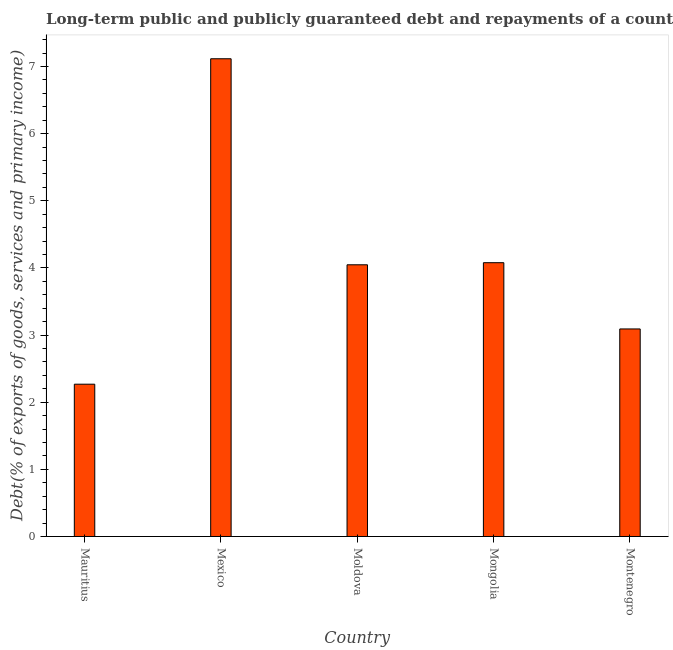Does the graph contain any zero values?
Your response must be concise. No. What is the title of the graph?
Keep it short and to the point. Long-term public and publicly guaranteed debt and repayments of a country to the IMF in 2009. What is the label or title of the X-axis?
Provide a succinct answer. Country. What is the label or title of the Y-axis?
Provide a short and direct response. Debt(% of exports of goods, services and primary income). What is the debt service in Mongolia?
Give a very brief answer. 4.08. Across all countries, what is the maximum debt service?
Give a very brief answer. 7.12. Across all countries, what is the minimum debt service?
Ensure brevity in your answer.  2.27. In which country was the debt service maximum?
Offer a terse response. Mexico. In which country was the debt service minimum?
Your answer should be compact. Mauritius. What is the sum of the debt service?
Offer a terse response. 20.6. What is the difference between the debt service in Mauritius and Mongolia?
Your answer should be very brief. -1.81. What is the average debt service per country?
Offer a very short reply. 4.12. What is the median debt service?
Your answer should be very brief. 4.05. What is the ratio of the debt service in Mauritius to that in Moldova?
Offer a terse response. 0.56. Is the debt service in Mongolia less than that in Montenegro?
Ensure brevity in your answer.  No. What is the difference between the highest and the second highest debt service?
Offer a terse response. 3.04. Is the sum of the debt service in Mongolia and Montenegro greater than the maximum debt service across all countries?
Offer a terse response. Yes. What is the difference between the highest and the lowest debt service?
Ensure brevity in your answer.  4.85. In how many countries, is the debt service greater than the average debt service taken over all countries?
Keep it short and to the point. 1. How many bars are there?
Your answer should be compact. 5. Are the values on the major ticks of Y-axis written in scientific E-notation?
Provide a succinct answer. No. What is the Debt(% of exports of goods, services and primary income) in Mauritius?
Provide a succinct answer. 2.27. What is the Debt(% of exports of goods, services and primary income) in Mexico?
Offer a terse response. 7.12. What is the Debt(% of exports of goods, services and primary income) in Moldova?
Give a very brief answer. 4.05. What is the Debt(% of exports of goods, services and primary income) of Mongolia?
Offer a very short reply. 4.08. What is the Debt(% of exports of goods, services and primary income) of Montenegro?
Give a very brief answer. 3.09. What is the difference between the Debt(% of exports of goods, services and primary income) in Mauritius and Mexico?
Ensure brevity in your answer.  -4.85. What is the difference between the Debt(% of exports of goods, services and primary income) in Mauritius and Moldova?
Your answer should be compact. -1.78. What is the difference between the Debt(% of exports of goods, services and primary income) in Mauritius and Mongolia?
Offer a terse response. -1.81. What is the difference between the Debt(% of exports of goods, services and primary income) in Mauritius and Montenegro?
Give a very brief answer. -0.82. What is the difference between the Debt(% of exports of goods, services and primary income) in Mexico and Moldova?
Keep it short and to the point. 3.07. What is the difference between the Debt(% of exports of goods, services and primary income) in Mexico and Mongolia?
Your answer should be very brief. 3.04. What is the difference between the Debt(% of exports of goods, services and primary income) in Mexico and Montenegro?
Your answer should be compact. 4.02. What is the difference between the Debt(% of exports of goods, services and primary income) in Moldova and Mongolia?
Offer a very short reply. -0.03. What is the difference between the Debt(% of exports of goods, services and primary income) in Moldova and Montenegro?
Keep it short and to the point. 0.96. What is the difference between the Debt(% of exports of goods, services and primary income) in Mongolia and Montenegro?
Provide a short and direct response. 0.99. What is the ratio of the Debt(% of exports of goods, services and primary income) in Mauritius to that in Mexico?
Give a very brief answer. 0.32. What is the ratio of the Debt(% of exports of goods, services and primary income) in Mauritius to that in Moldova?
Provide a succinct answer. 0.56. What is the ratio of the Debt(% of exports of goods, services and primary income) in Mauritius to that in Mongolia?
Give a very brief answer. 0.56. What is the ratio of the Debt(% of exports of goods, services and primary income) in Mauritius to that in Montenegro?
Give a very brief answer. 0.73. What is the ratio of the Debt(% of exports of goods, services and primary income) in Mexico to that in Moldova?
Your answer should be compact. 1.76. What is the ratio of the Debt(% of exports of goods, services and primary income) in Mexico to that in Mongolia?
Offer a very short reply. 1.75. What is the ratio of the Debt(% of exports of goods, services and primary income) in Mexico to that in Montenegro?
Make the answer very short. 2.3. What is the ratio of the Debt(% of exports of goods, services and primary income) in Moldova to that in Mongolia?
Ensure brevity in your answer.  0.99. What is the ratio of the Debt(% of exports of goods, services and primary income) in Moldova to that in Montenegro?
Your answer should be compact. 1.31. What is the ratio of the Debt(% of exports of goods, services and primary income) in Mongolia to that in Montenegro?
Your response must be concise. 1.32. 